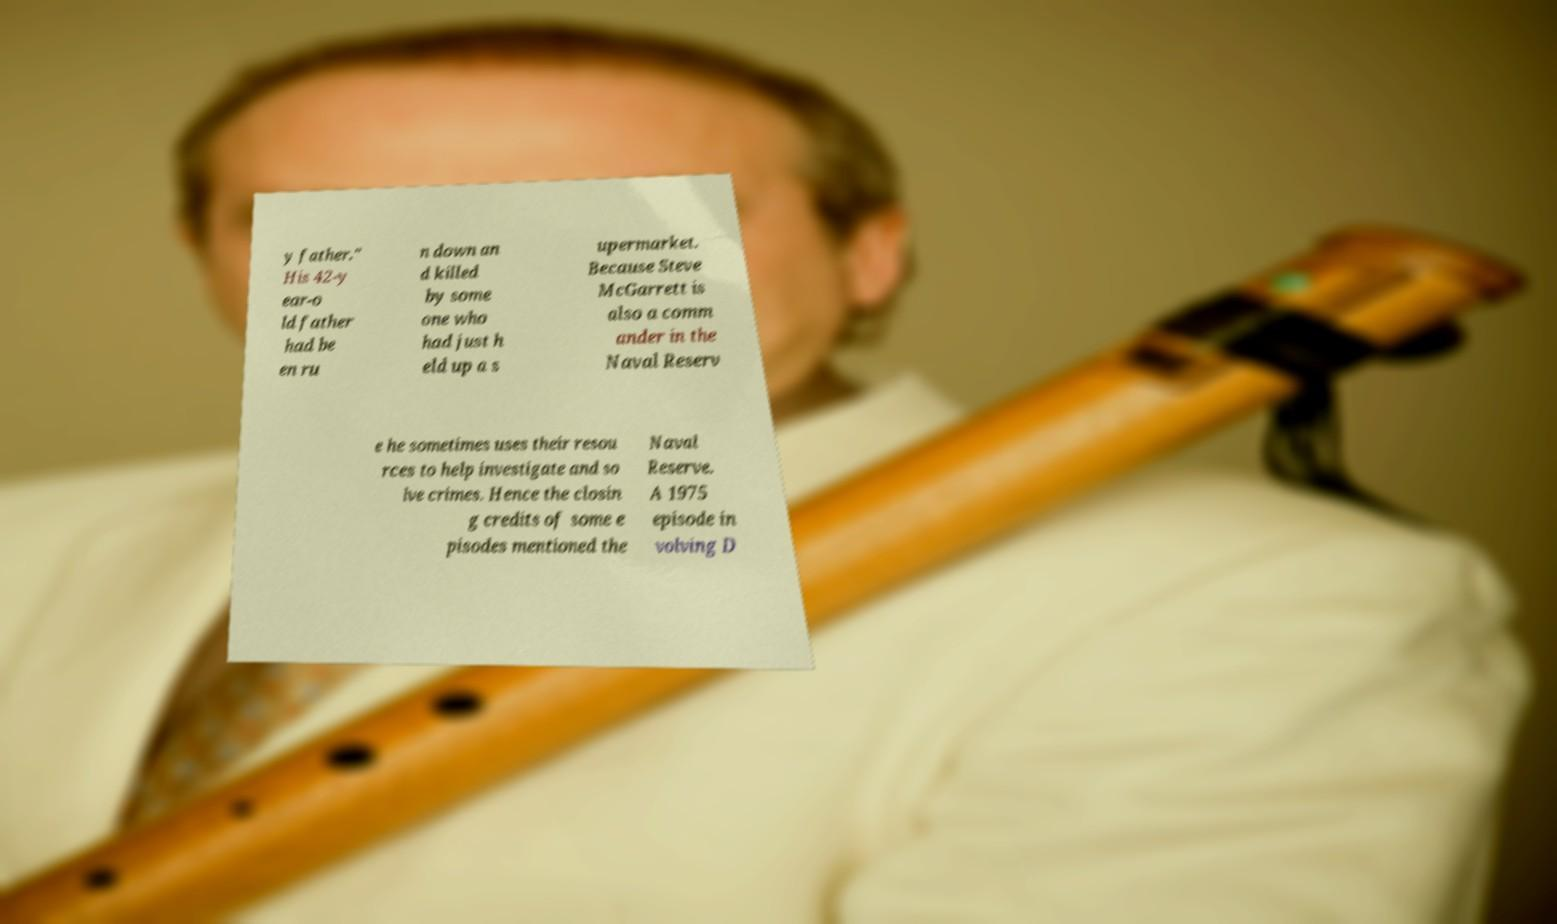Could you assist in decoding the text presented in this image and type it out clearly? y father." His 42-y ear-o ld father had be en ru n down an d killed by some one who had just h eld up a s upermarket. Because Steve McGarrett is also a comm ander in the Naval Reserv e he sometimes uses their resou rces to help investigate and so lve crimes. Hence the closin g credits of some e pisodes mentioned the Naval Reserve. A 1975 episode in volving D 